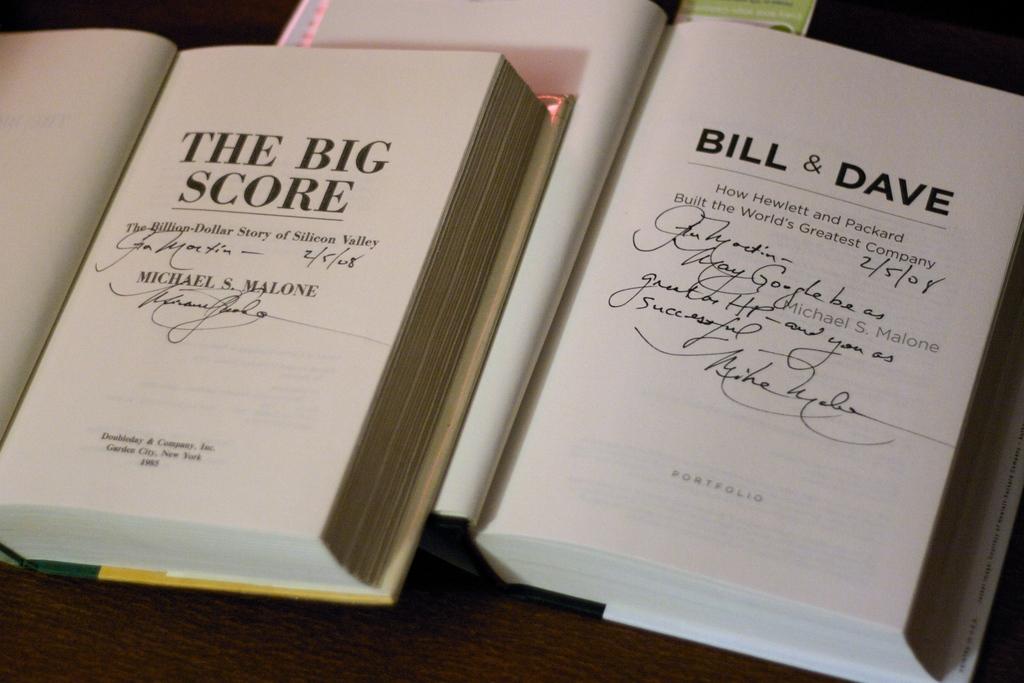Who wrote the big score?
Give a very brief answer. Michael s. malone. What is the book on the right?
Offer a terse response. Bill & dave. 